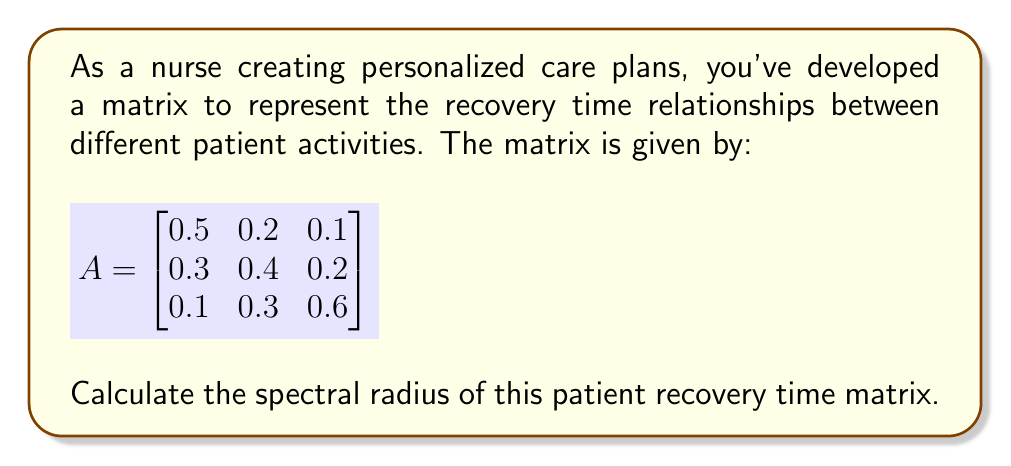What is the answer to this math problem? To find the spectral radius of matrix A, we need to follow these steps:

1. Calculate the characteristic polynomial of A:
   $$det(A - \lambda I) = 0$$
   
   $$\begin{vmatrix}
   0.5-\lambda & 0.2 & 0.1 \\
   0.3 & 0.4-\lambda & 0.2 \\
   0.1 & 0.3 & 0.6-\lambda
   \end{vmatrix} = 0$$

2. Expand the determinant:
   $$(0.5-\lambda)[(0.4-\lambda)(0.6-\lambda)-0.06] - 0.2[0.3(0.6-\lambda)-0.02] + 0.1[0.3(0.4-\lambda)-0.06] = 0$$

3. Simplify:
   $$-\lambda^3 + 1.5\lambda^2 - 0.61\lambda + 0.076 = 0$$

4. Find the roots of this cubic equation. These are the eigenvalues of A. We can use a numerical method or a computer algebra system to find:
   $$\lambda_1 \approx 0.9053$$
   $$\lambda_2 \approx 0.3973$$
   $$\lambda_3 \approx 0.1974$$

5. The spectral radius is the maximum absolute value of these eigenvalues:
   $$\rho(A) = \max(|\lambda_1|, |\lambda_2|, |\lambda_3|) = |\lambda_1| \approx 0.9053$$
Answer: $0.9053$ 